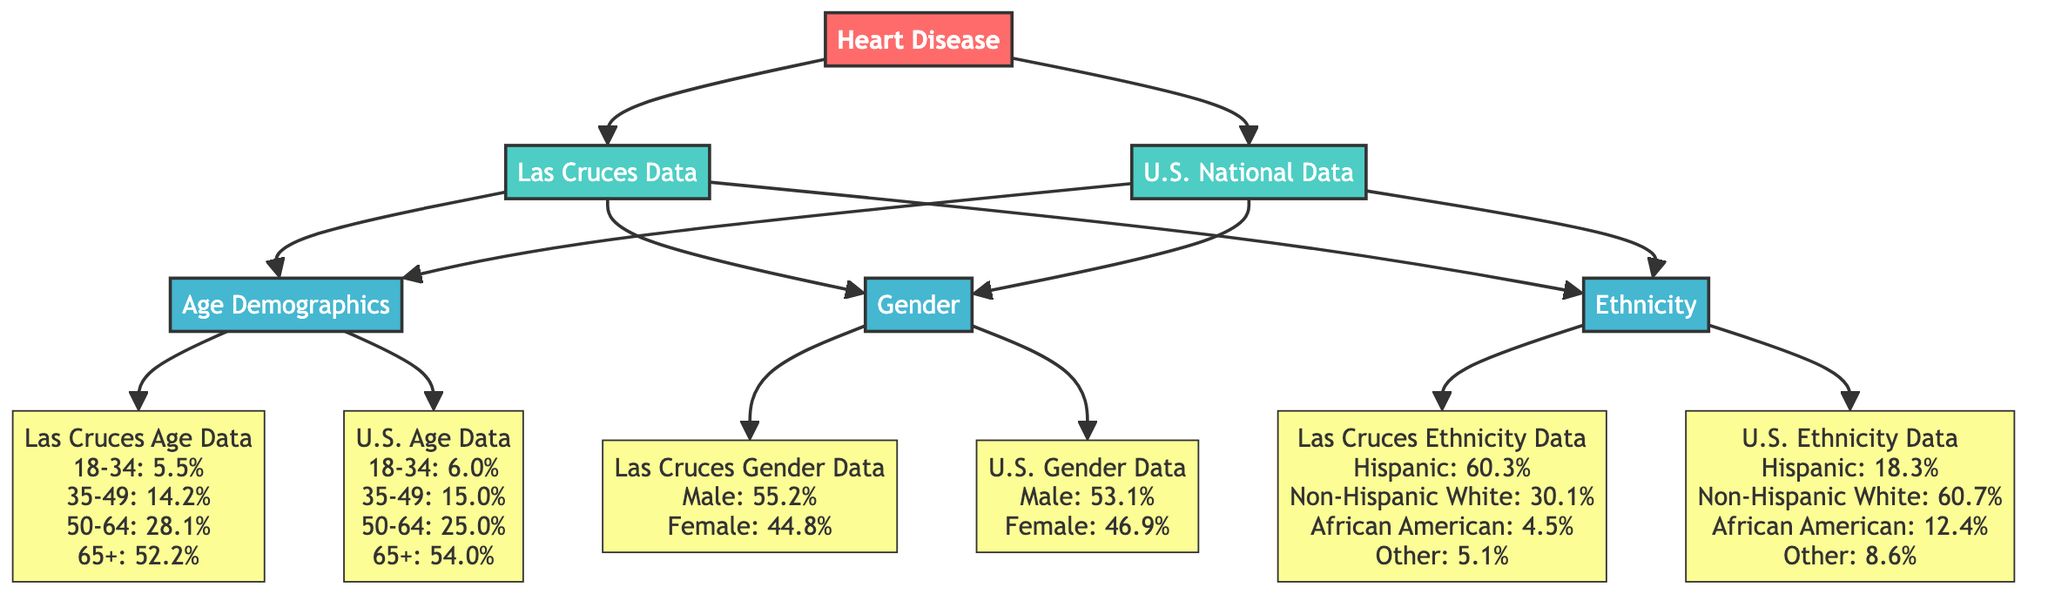What is the percentage of heart disease prevalence for the age group 65+ in Las Cruces? According to the diagram, the heart disease prevalence for the age group 65+ in Las Cruces is directly found in the node labeled "Las Cruces Age Data," which indicates 52.2%.
Answer: 52.2% What is the total percentage of heart disease prevalence for males in the U.S.? The diagram provides the percentage for U.S. males in the node labeled "U.S. Gender Data," which states that 53.1% of heart disease cases are in males.
Answer: 53.1% Which demographic has the highest representation in Las Cruces according to ethnicity? The "Las Cruces Ethnicity Data" node informs us that the Hispanic demographic has the highest representation at 60.3%.
Answer: Hispanic How does the age group percentage of Las Cruces compare to the U.S. for ages 50-64? To find this, we look at both the "Las Cruces Age Data" and the "U.S. Age Data" nodes, which show 28.1% for Las Cruces and 25.0% for the U.S., respectively. Since 28.1% is greater than 25.0%, we conclude that Las Cruces has a higher percentage in this age group.
Answer: Higher What is the percentage of Non-Hispanic White individuals with heart disease in the U.S.? The node "U.S. Ethnicity Data" reveals that Non-Hispanic White individuals have a prevalence of 60.7% for heart disease.
Answer: 60.7% Which age group has the lowest percentage of heart disease in Las Cruces? By examining the "Las Cruces Age Data," we can see that the age group 18-34 has the lowest prevalence at 5.5%, as it is the smallest value among all age groups.
Answer: 5.5% How does the percentage of heart disease in the 35-49 age group in Las Cruces compare with the national data? The "Las Cruces Age Data" shows 14.2% for the 35-49 age group, while the "U.S. Age Data" shows 15.0%. Since 14.2% is less than 15.0%, Las Cruces has a lower percentage for this group.
Answer: Lower What percentage of heart disease cases in Las Cruces are attributed to African Americans? The diagram's "Las Cruces Ethnicity Data" specifies that African Americans account for 4.5% of heart disease cases.
Answer: 4.5% Which age group has the highest percentage of heart disease in U.S. National Data? The "U.S. Age Data" node indicates that the 65+ age group has the highest percentage at 54.0%, which is the largest value among the listed age groups.
Answer: 54.0% 